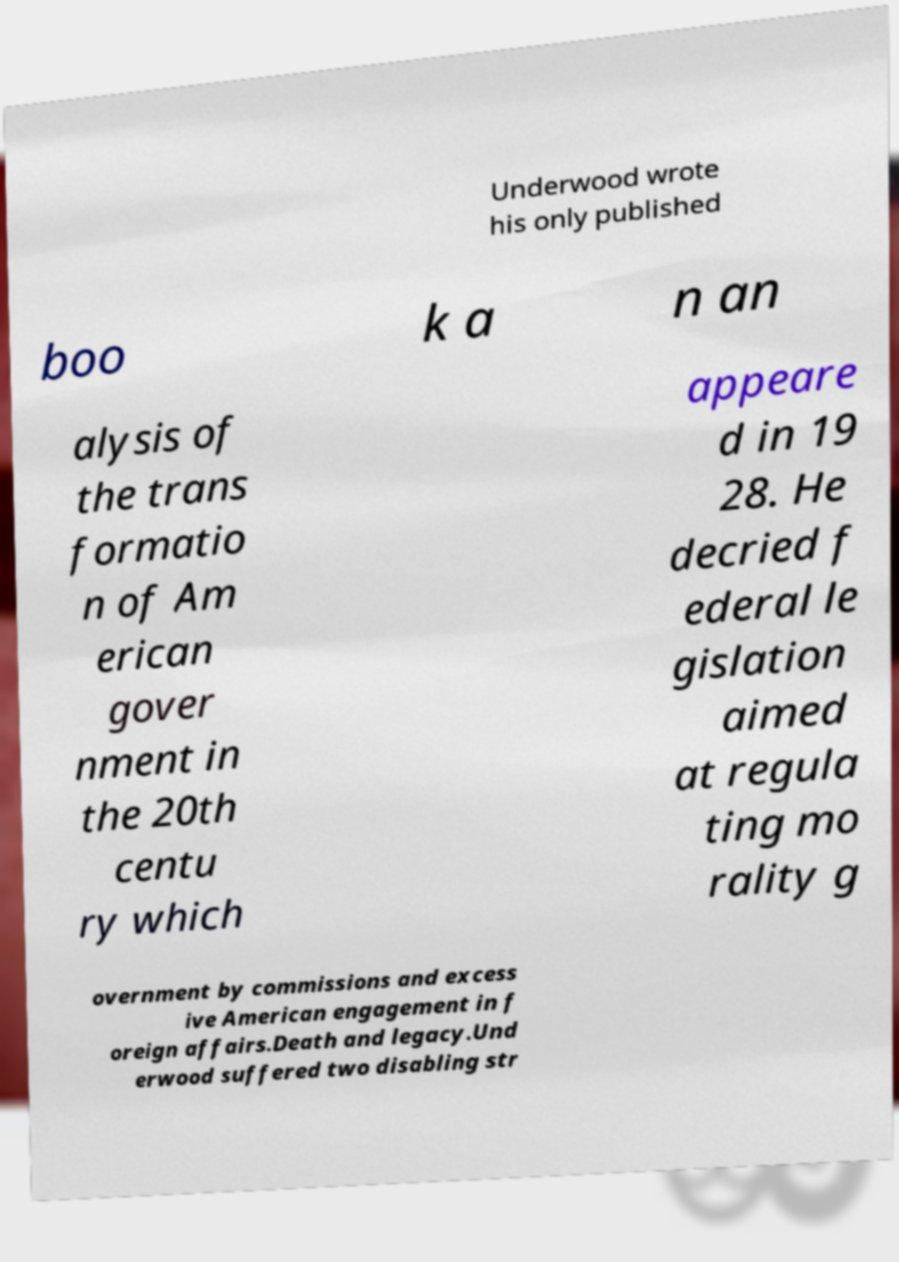Please read and relay the text visible in this image. What does it say? Underwood wrote his only published boo k a n an alysis of the trans formatio n of Am erican gover nment in the 20th centu ry which appeare d in 19 28. He decried f ederal le gislation aimed at regula ting mo rality g overnment by commissions and excess ive American engagement in f oreign affairs.Death and legacy.Und erwood suffered two disabling str 